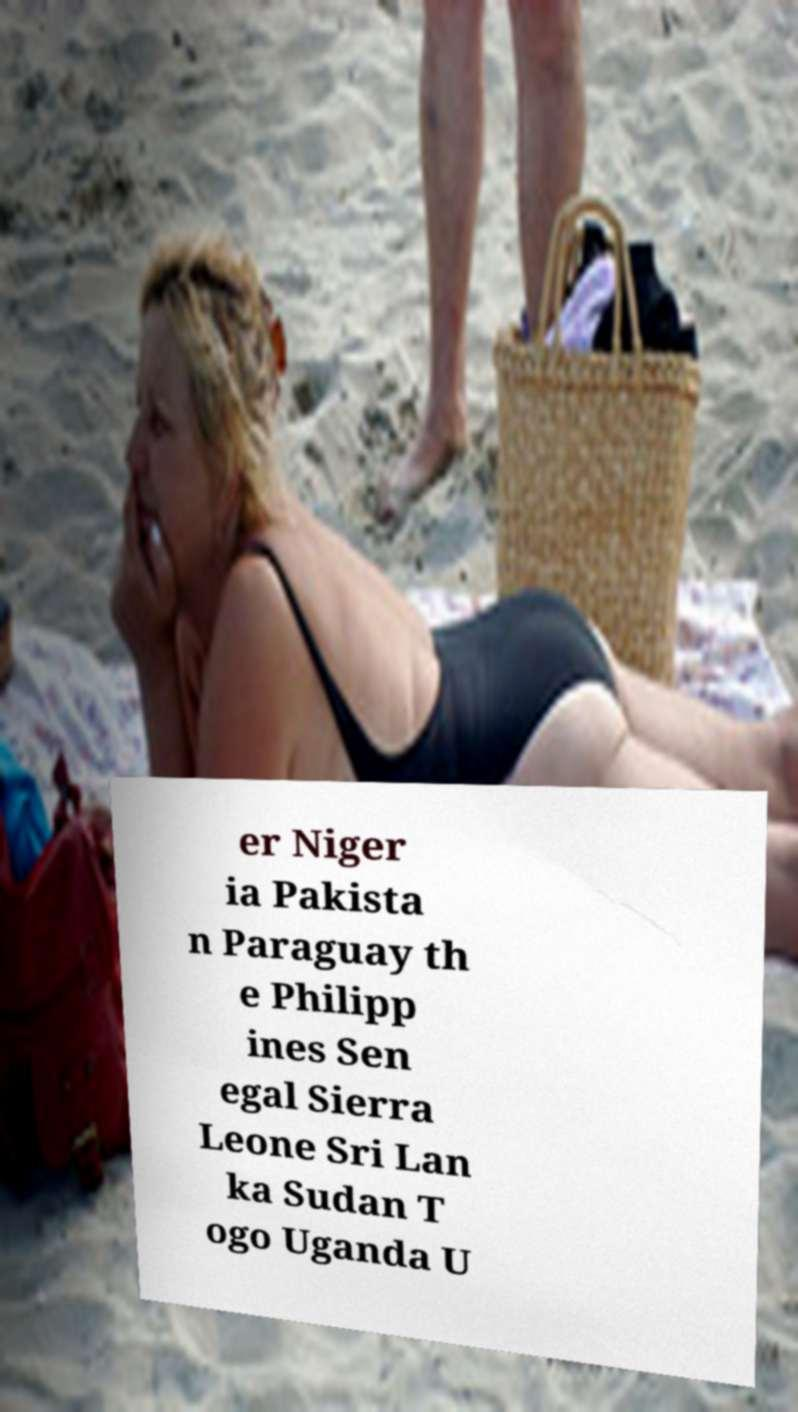Could you extract and type out the text from this image? er Niger ia Pakista n Paraguay th e Philipp ines Sen egal Sierra Leone Sri Lan ka Sudan T ogo Uganda U 